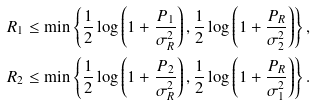Convert formula to latex. <formula><loc_0><loc_0><loc_500><loc_500>& R _ { 1 } \leq \min \left \{ \frac { 1 } { 2 } \log \left ( 1 + \frac { P _ { 1 } } { \sigma _ { R } ^ { 2 } } \right ) , \frac { 1 } { 2 } \log \left ( 1 + \frac { P _ { R } } { \sigma _ { 2 } ^ { 2 } } \right ) \right \} \text  , \\ &R_{2} \leq \min \left \{ \frac { 1 } { 2 } \log \left ( 1 + \frac { P _ { 2 } } { \sigma _ { R } ^ { 2 } } \right ) , \frac { 1 } { 2 } \log \left ( 1 + \frac { P _ { R } } { \sigma _ { 1 } ^ { 2 } } \right ) \right \} \text  .</formula> 